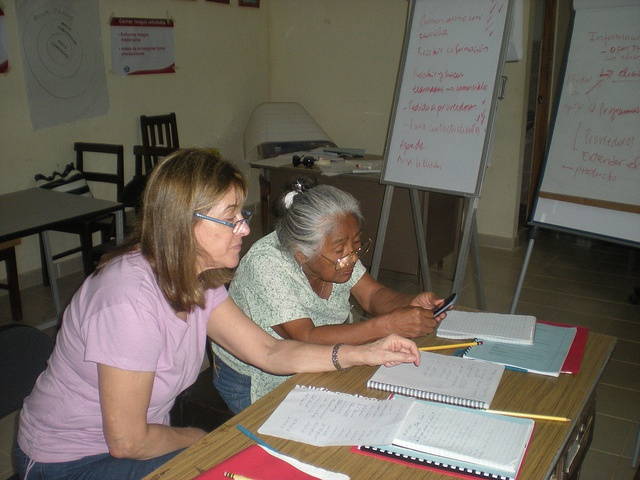Describe the objects in this image and their specific colors. I can see people in gray, darkgray, tan, and pink tones, people in gray, darkgray, brown, and maroon tones, book in gray, lightgray, lightblue, and darkgray tones, dining table in gray and black tones, and book in gray, darkgray, and lightgray tones in this image. 